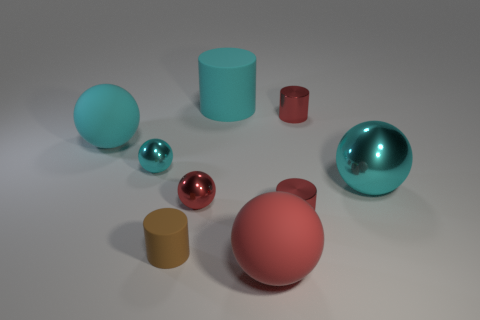Subtract all cyan spheres. How many were subtracted if there are1cyan spheres left? 2 Subtract all brown blocks. How many cyan balls are left? 3 Subtract all brown cylinders. How many cylinders are left? 3 Subtract all tiny red spheres. How many spheres are left? 4 Subtract all green spheres. Subtract all blue cylinders. How many spheres are left? 5 Add 1 small yellow matte cylinders. How many objects exist? 10 Subtract all spheres. How many objects are left? 4 Subtract all big cylinders. Subtract all large red spheres. How many objects are left? 7 Add 2 small brown cylinders. How many small brown cylinders are left? 3 Add 2 large gray cubes. How many large gray cubes exist? 2 